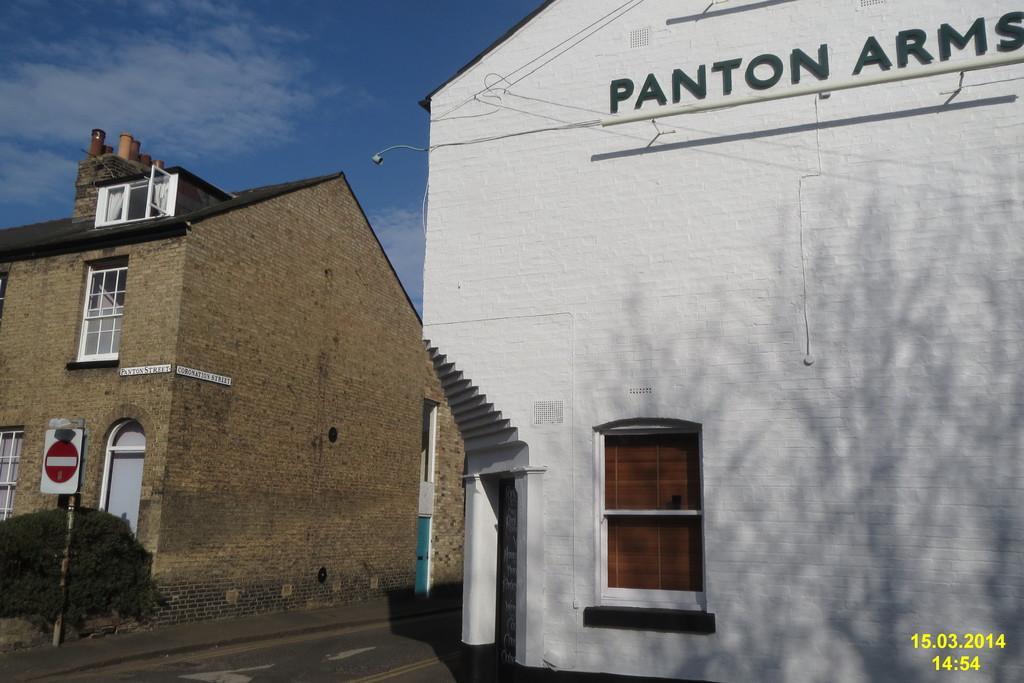Provide a one-sentence caption for the provided image. The company name is called pantom arms and is written on the building. 